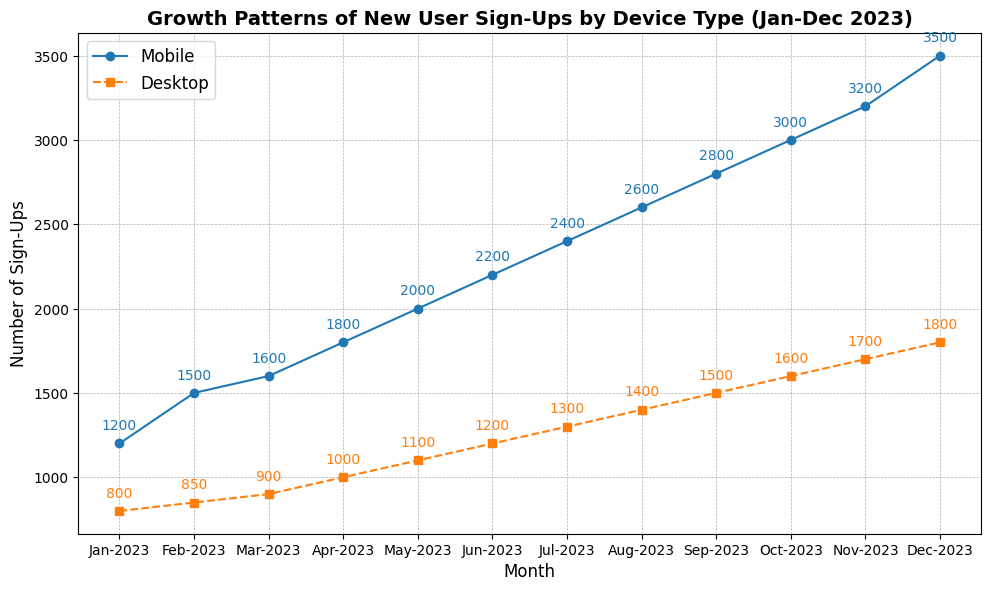What month saw the highest number of new user sign-ups on mobile devices? By looking at the figure, identify the peak point on the line representing mobile sign-ups. The highest point corresponds to December 2023 with 3500 new user sign-ups.
Answer: December 2023 Which device type consistently had lower sign-up numbers throughout the year, mobile or desktop? Compare the sign-up numbers for mobile and desktop for each month visually. The line for desktop sign-ups is consistently below the line for mobile sign-ups throughout the year.
Answer: Desktop What is the difference in the number of sign-ups between mobile and desktop users in December 2023? Find the number of sign-ups for both mobile (3500) and desktop (1800) in December 2023 from the figure and subtract the desktop sign-ups from the mobile sign-ups (3500 - 1800 = 1700).
Answer: 1700 In which month did the desktop users see the first increase of over 1000 sign-ups? Scan the sign-up numbers for desktop up to the month in which they exceed 1000 sign-ups. This occurred in April 2023.
Answer: April 2023 Calculate the average monthly sign-ups for mobile users across the year. Sum the sign-up numbers for each month (1200 + 1500 + 1600 + 1800 + 2000 + 2200 + 2400 + 2600 + 2800 + 3000 + 3200 + 3500 = 27800) and divide by the number of months (12). The average is 27800 / 12 ≈ 2316.67.
Answer: 2316.67 Which month experienced the highest increase in mobile sign-ups compared to the previous month? Determine the difference in sign-ups between consecutive months for mobile users and identify the month with the maximum difference. July 2023 (2400) compared to June 2023 (2200) shows the highest monthly increase (2400 - 2200 = 200).
Answer: July 2023 What is the ratio of mobile to desktop sign-ups in October 2023? Identify the sign-up numbers for both mobile (3000) and desktop (1600) in October 2023 from the figure and calculate the ratio (3000 / 1600 = 1.875).
Answer: 1.875 Is the growth pattern for mobile sign-ups linear, exponential, or does it follow another pattern? Visually inspect the trend line for mobile sign-ups. It shows a consistent, steady increase, suggestive of a linear growth pattern.
Answer: Linear Identify the month with the smallest difference in sign-ups between mobile and desktop users. Calculate the differences in sign-up numbers between mobile and desktop users for each month and identify the smallest value. February 2023 has the smallest difference (1500 - 850 = 650).
Answer: February 2023 By how much did the number of desktop sign-ups increase from January 2023 to December 2023? Find the sign-up numbers for desktop in January 2023 (800) and December 2023 (1800) and calculate the difference (1800 - 800 = 1000).
Answer: 1000 